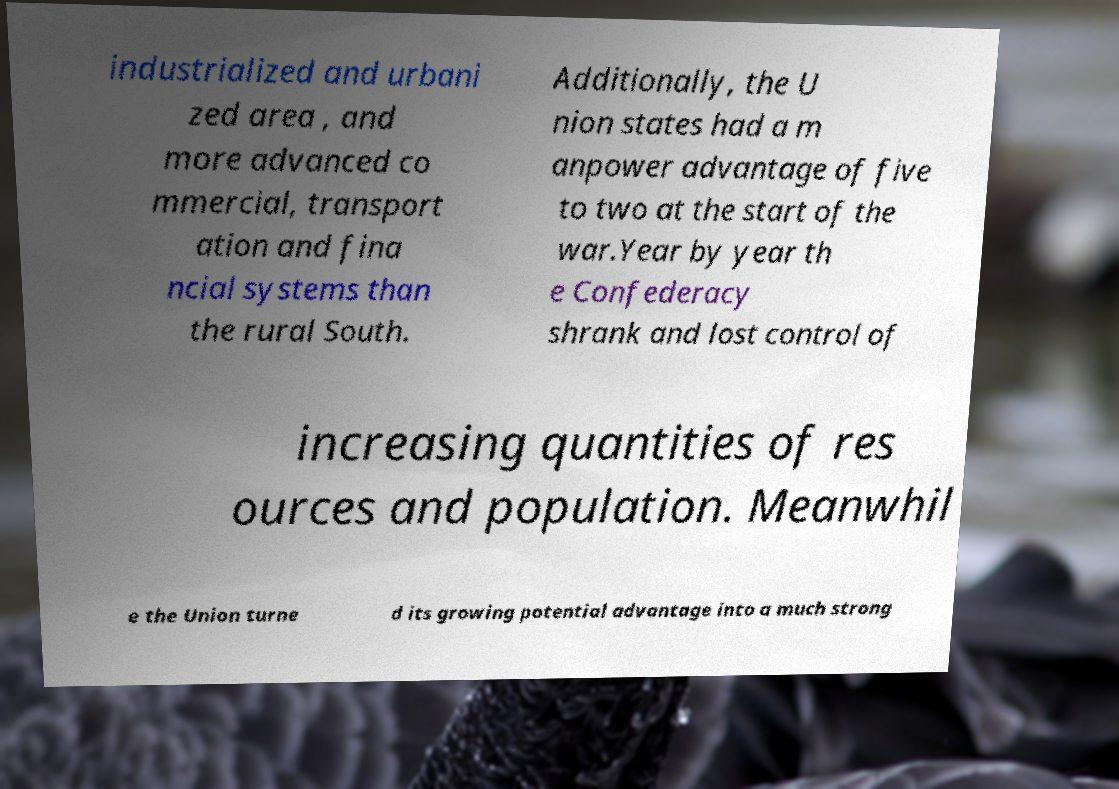Can you accurately transcribe the text from the provided image for me? industrialized and urbani zed area , and more advanced co mmercial, transport ation and fina ncial systems than the rural South. Additionally, the U nion states had a m anpower advantage of five to two at the start of the war.Year by year th e Confederacy shrank and lost control of increasing quantities of res ources and population. Meanwhil e the Union turne d its growing potential advantage into a much strong 